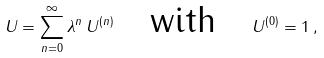Convert formula to latex. <formula><loc_0><loc_0><loc_500><loc_500>U = \sum _ { n = 0 } ^ { \infty } \lambda ^ { n } \, U ^ { ( n ) } \quad \text {with} \quad U ^ { ( 0 ) } = 1 \, ,</formula> 